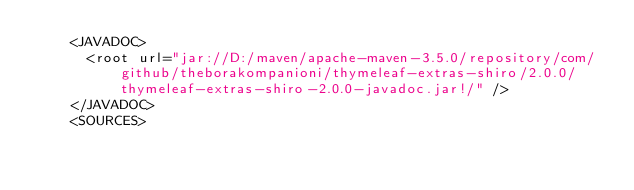<code> <loc_0><loc_0><loc_500><loc_500><_XML_>    <JAVADOC>
      <root url="jar://D:/maven/apache-maven-3.5.0/repository/com/github/theborakompanioni/thymeleaf-extras-shiro/2.0.0/thymeleaf-extras-shiro-2.0.0-javadoc.jar!/" />
    </JAVADOC>
    <SOURCES></code> 